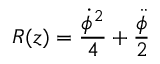Convert formula to latex. <formula><loc_0><loc_0><loc_500><loc_500>R ( z ) = \frac { \dot { \phi } ^ { 2 } } { 4 } + \frac { \ddot { \phi } } { 2 }</formula> 